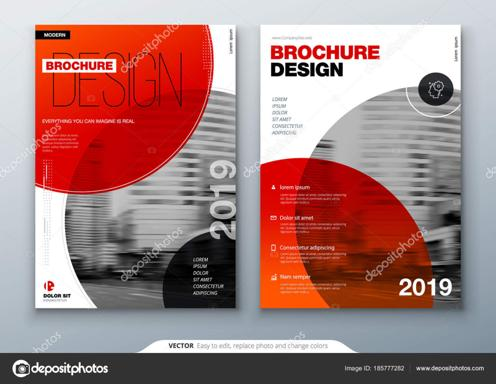What are some features of this brochure template mentioned in the image? The brochure template boasts several user-friendly features, including ease of editing which allows for full customization of text and design elements. Users can conveniently replace photos and modify the color palette to suit their preferences or brand identity. Notably, this template is accessible on www.depositphotos.com with the Image ID 185777282, providing further resources for users seeking additional images or designs. 